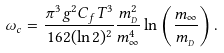<formula> <loc_0><loc_0><loc_500><loc_500>\omega _ { c } = \frac { \pi ^ { 3 } g ^ { 2 } C _ { f } T ^ { 3 } } { 1 6 2 ( \ln 2 ) ^ { 2 } } \frac { m _ { _ { D } } ^ { 2 } } { m _ { \infty } ^ { 4 } } \ln \left ( \frac { m _ { \infty } } { m _ { _ { D } } } \right ) .</formula> 